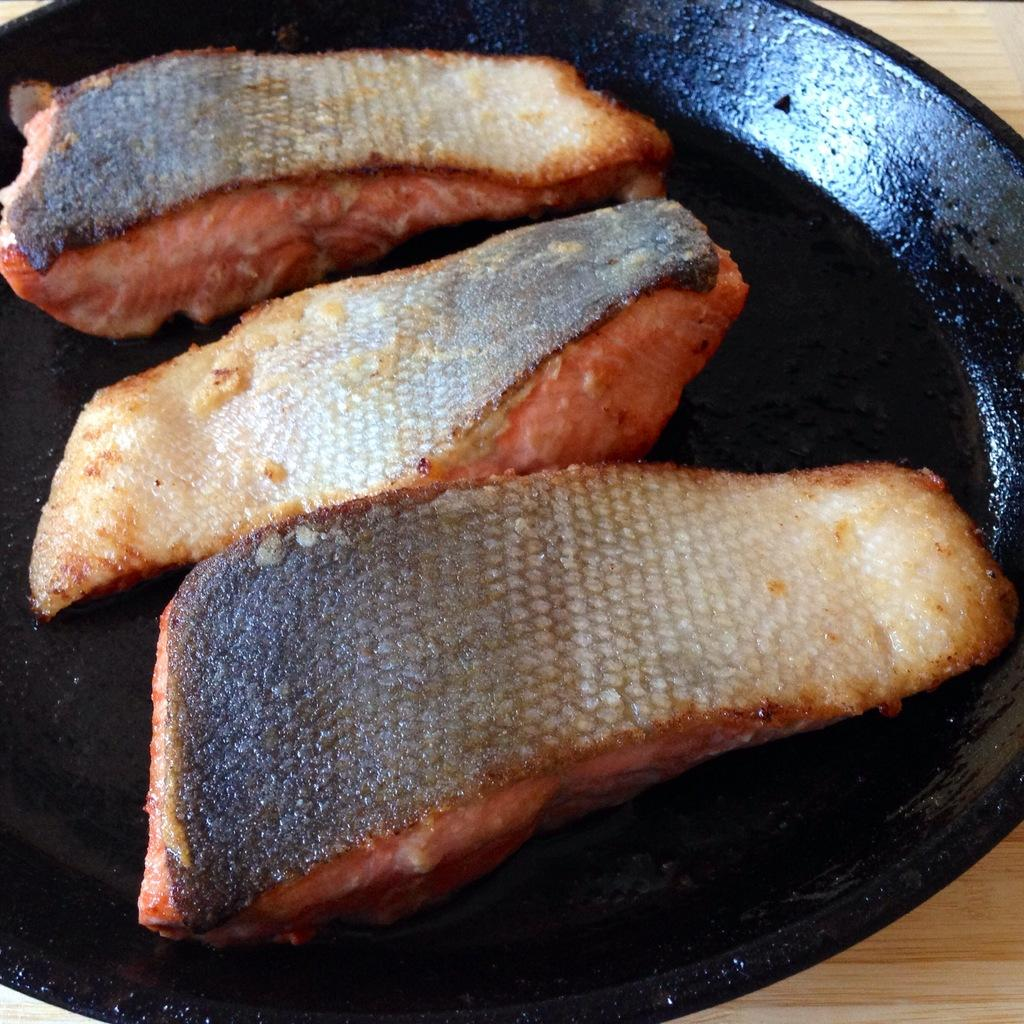What type of objects can be seen in the image? There are food items in the image. What is the color of the pan containing the food items? The pan is black in color. On what surface is the pan placed? The pan is on a wooden surface. What position does the beginner take when sitting on the chair in the image? There is no chair or person in the image, so this question cannot be answered. 